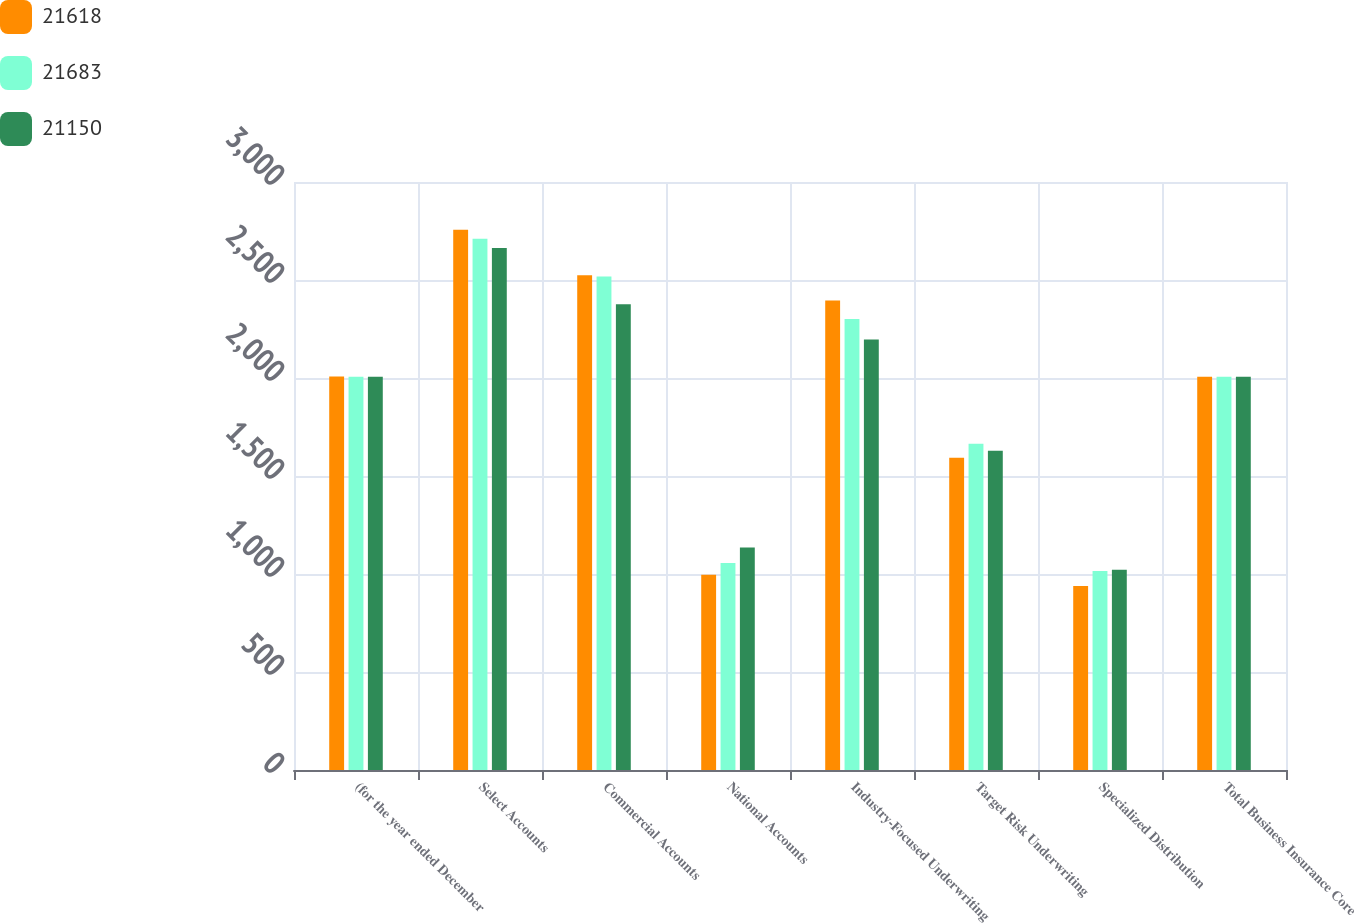<chart> <loc_0><loc_0><loc_500><loc_500><stacked_bar_chart><ecel><fcel>(for the year ended December<fcel>Select Accounts<fcel>Commercial Accounts<fcel>National Accounts<fcel>Industry-Focused Underwriting<fcel>Target Risk Underwriting<fcel>Specialized Distribution<fcel>Total Business Insurance Core<nl><fcel>21618<fcel>2008<fcel>2756<fcel>2524<fcel>996<fcel>2396<fcel>1593<fcel>939<fcel>2007<nl><fcel>21683<fcel>2007<fcel>2711<fcel>2518<fcel>1056<fcel>2301<fcel>1665<fcel>1015<fcel>2007<nl><fcel>21150<fcel>2006<fcel>2663<fcel>2376<fcel>1135<fcel>2196<fcel>1629<fcel>1022<fcel>2007<nl></chart> 